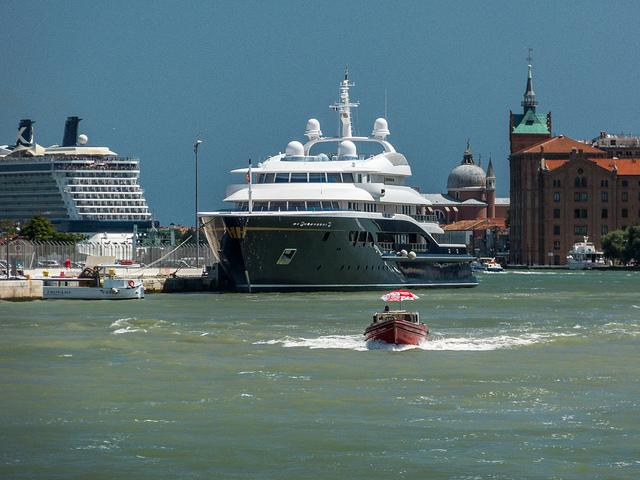Which direction is the large gray ship going? Please explain your reasoning. no where. The large gray ship is anchored. it is stationary. 